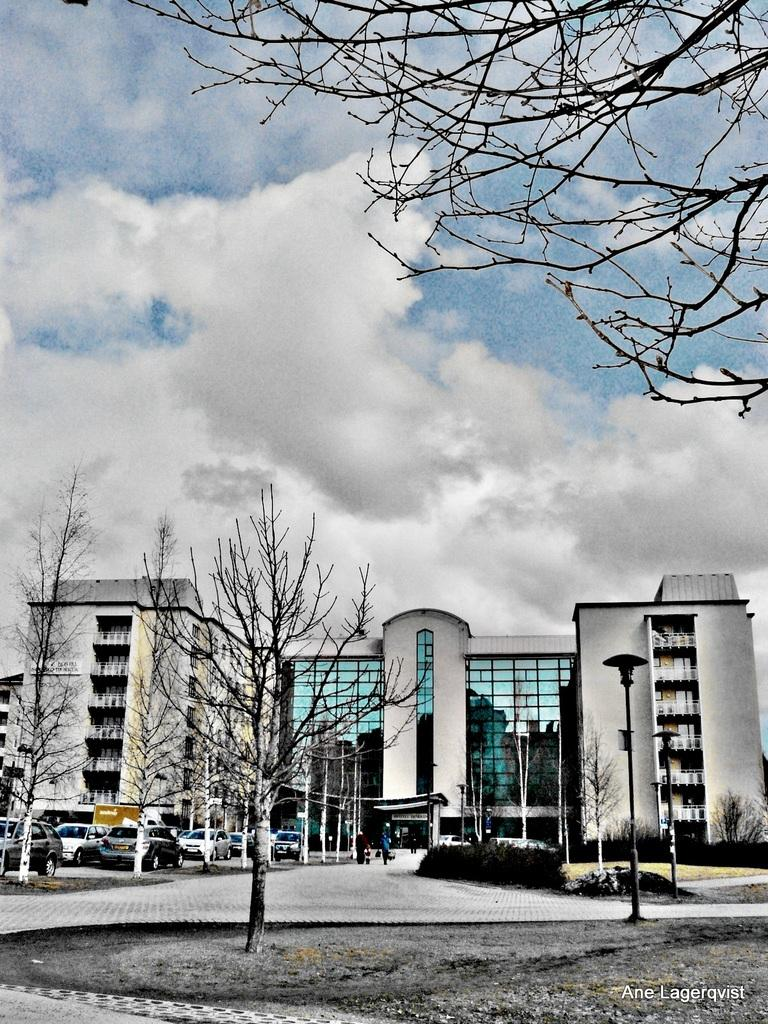What can be seen in the foreground of the image? In the foreground of the image, there is a road, trees, and vehicles. Can you describe the tree in the right bottom corner of the image? Yes, there is a tree in the right bottom corner of the image. What is visible in the background of the image? In the background of the image, there is a building, poles, plants, and the sky. Where is the basin located in the image? There is no basin present in the image. What type of channel can be seen in the image? There is no channel present in the image. 